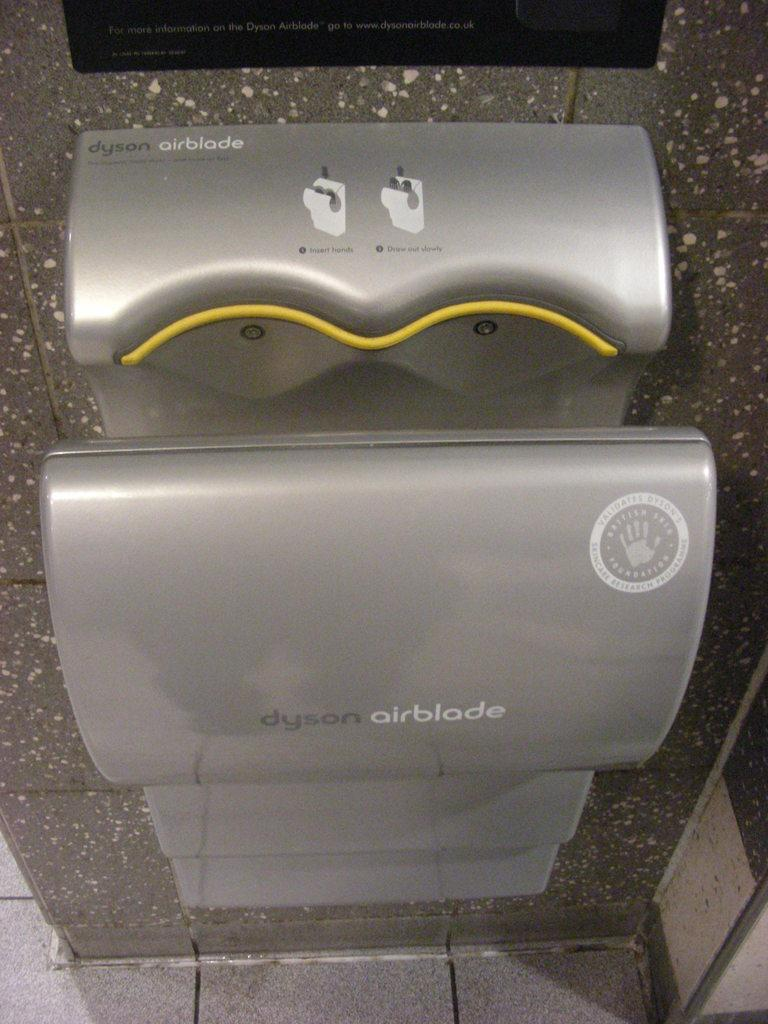<image>
Offer a succinct explanation of the picture presented. Dyson airblade wall-mounted hand dryer with instructions on how to use it on top, includes one blower for each hand. 